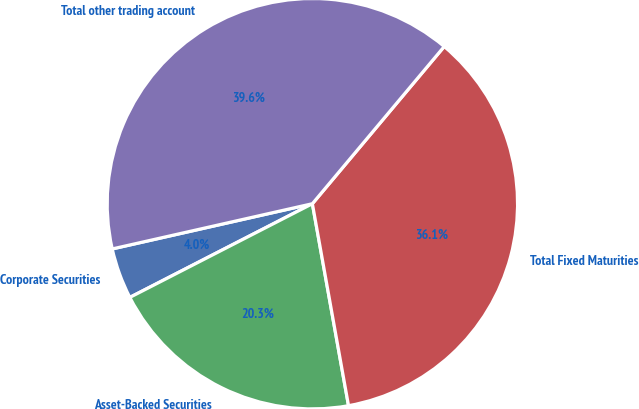<chart> <loc_0><loc_0><loc_500><loc_500><pie_chart><fcel>Corporate Securities<fcel>Asset-Backed Securities<fcel>Total Fixed Maturities<fcel>Total other trading account<nl><fcel>4.01%<fcel>20.27%<fcel>36.07%<fcel>39.64%<nl></chart> 